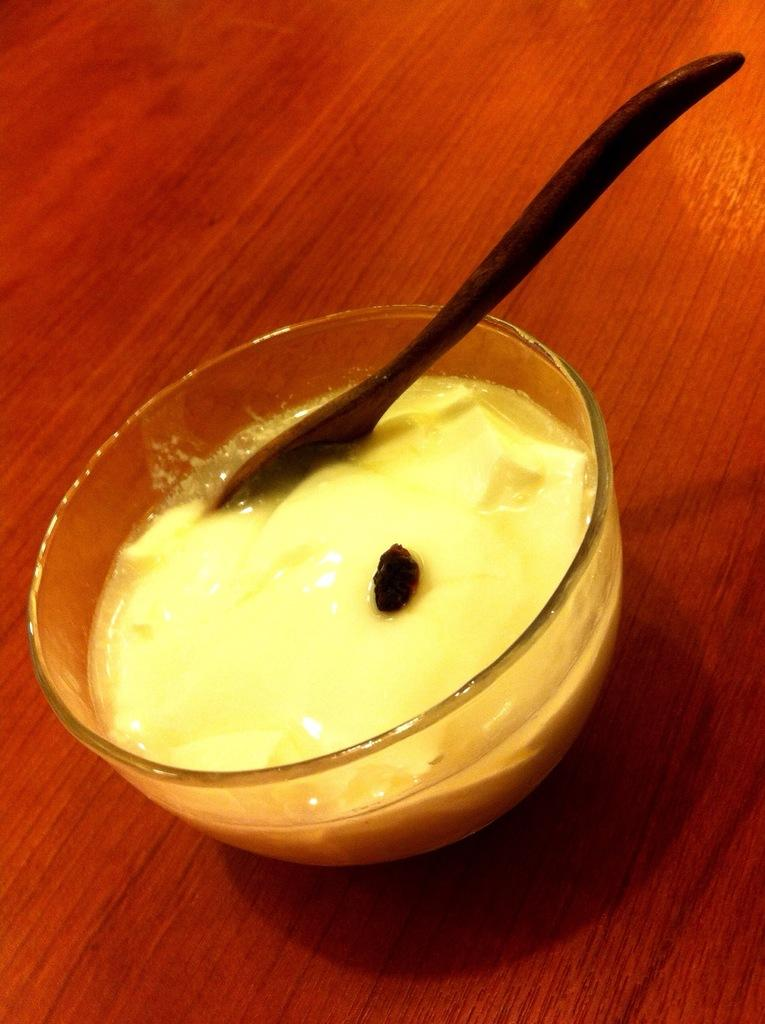What is in the bowl that is visible in the image? There is food in a bowl in the image. What utensil is used to eat the food in the image? There is a spoon in the bowl in the image. What type of flooring can be seen in the image? The floor in the image appears to be wooden. How many beads are scattered on the wooden floor in the image? There are no beads visible on the wooden floor in the image. 